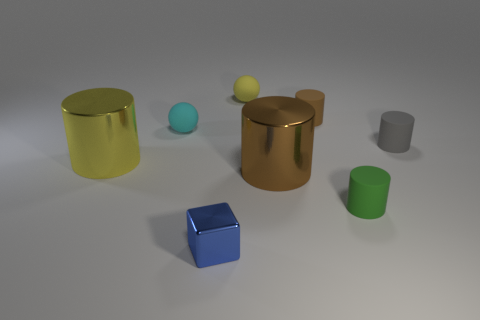Subtract all matte cylinders. How many cylinders are left? 2 Subtract all yellow balls. How many balls are left? 1 Subtract all spheres. How many objects are left? 6 Add 1 metallic cylinders. How many objects exist? 9 Subtract 1 blocks. How many blocks are left? 0 Add 3 small brown rubber things. How many small brown rubber things are left? 4 Add 4 small green matte things. How many small green matte things exist? 5 Subtract 0 green balls. How many objects are left? 8 Subtract all purple balls. Subtract all red cylinders. How many balls are left? 2 Subtract all red cylinders. How many cyan balls are left? 1 